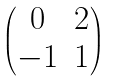Convert formula to latex. <formula><loc_0><loc_0><loc_500><loc_500>\begin{pmatrix} 0 & 2 \\ - 1 & 1 \end{pmatrix}</formula> 